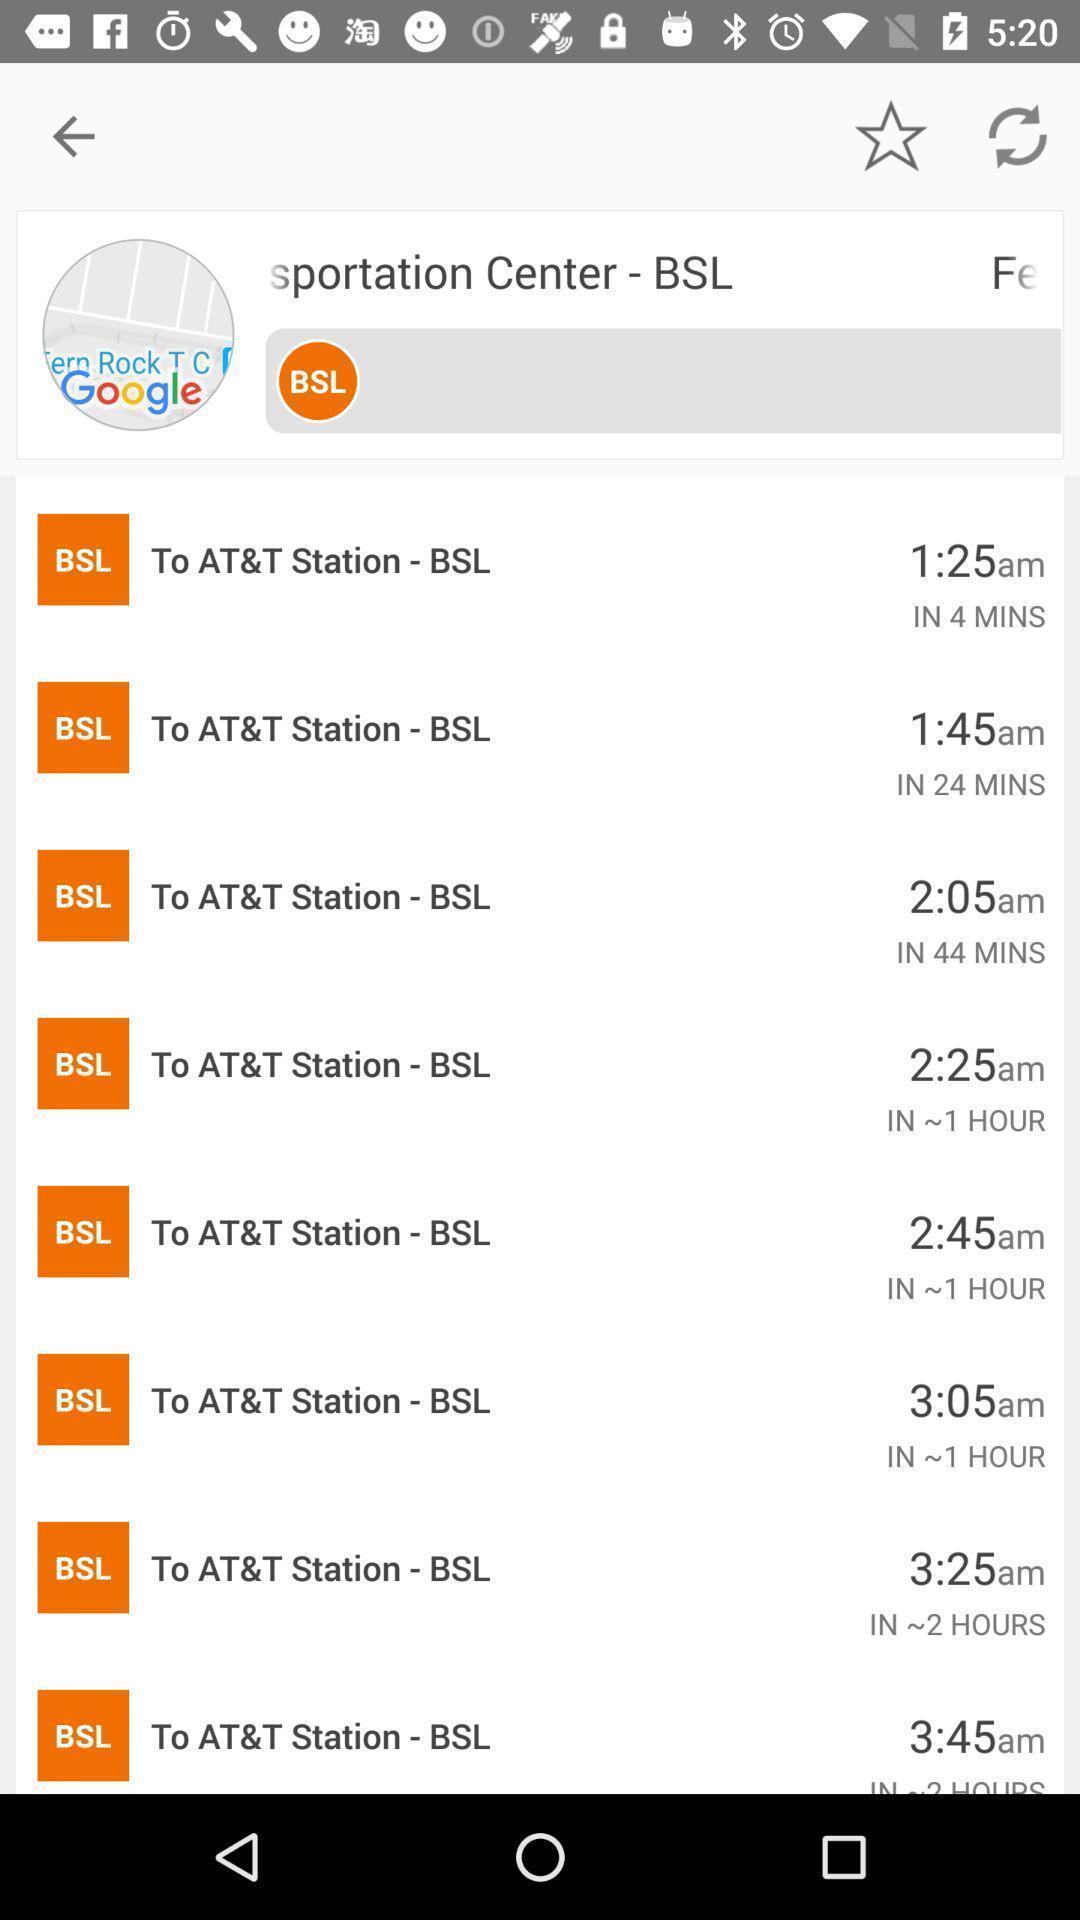What details can you identify in this image? Page that displaying schedule time. 